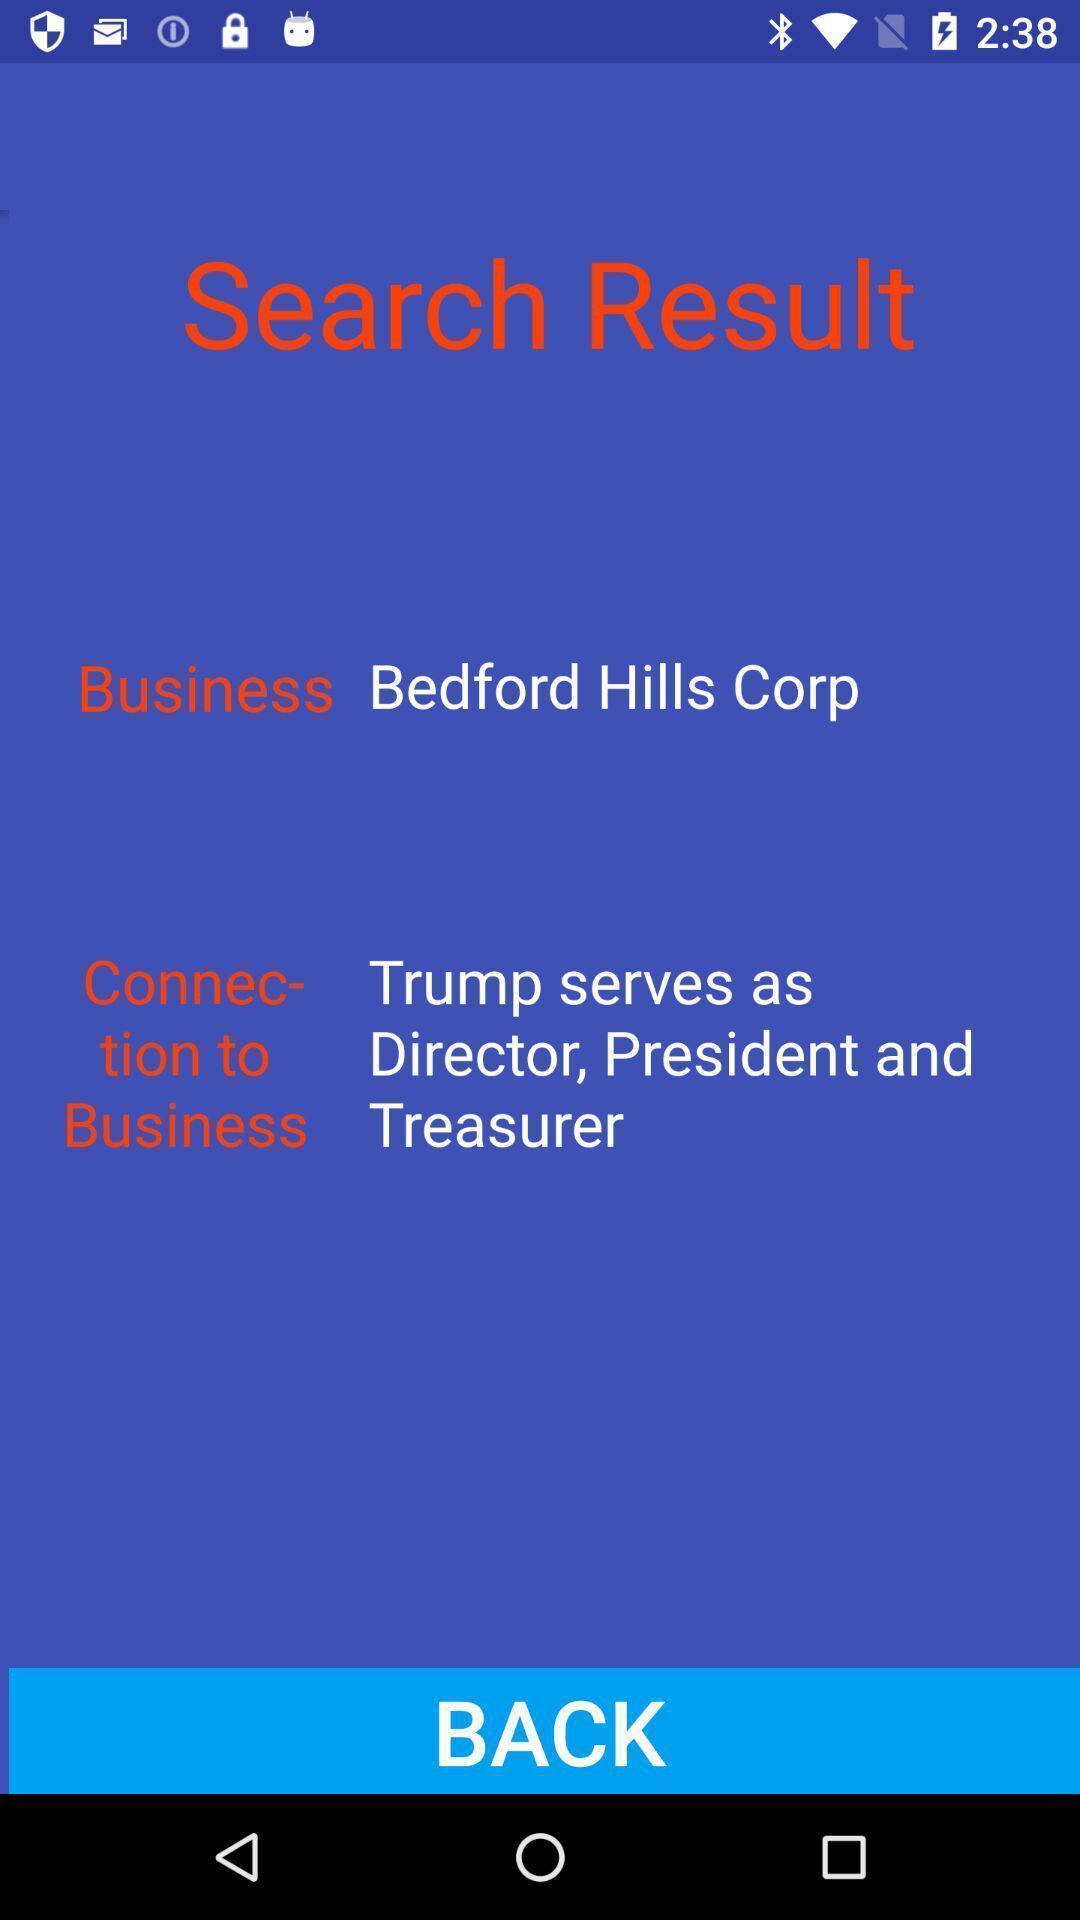Provide a description of this screenshot. Search result page displayed. 